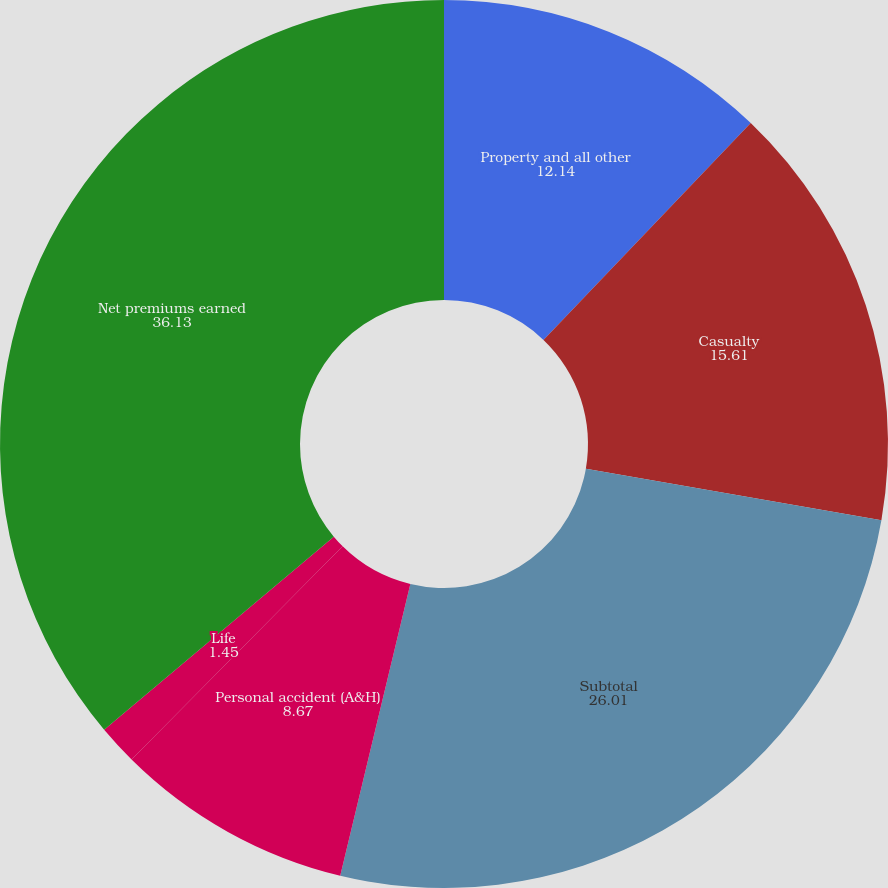Convert chart to OTSL. <chart><loc_0><loc_0><loc_500><loc_500><pie_chart><fcel>Property and all other<fcel>Casualty<fcel>Subtotal<fcel>Personal accident (A&H)<fcel>Life<fcel>Net premiums earned<nl><fcel>12.14%<fcel>15.61%<fcel>26.01%<fcel>8.67%<fcel>1.45%<fcel>36.13%<nl></chart> 